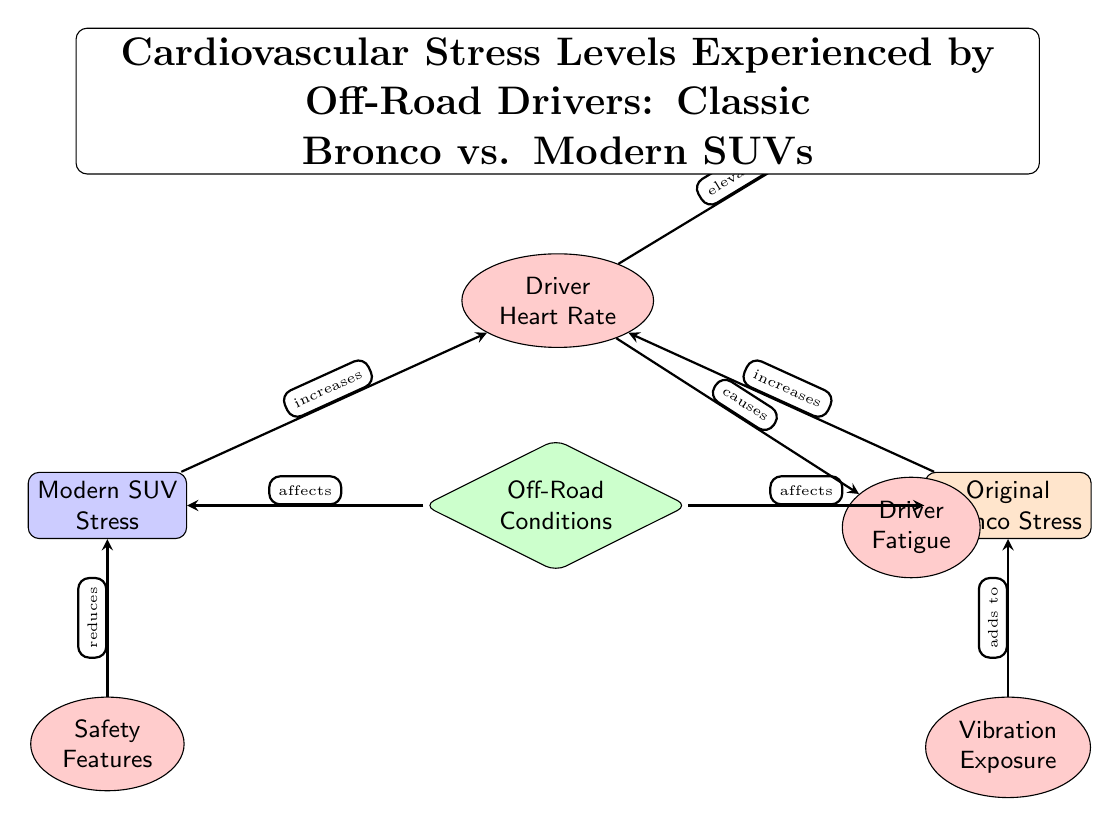What condition affects both vehicle types? The diagram indicates "Off-Road Conditions" as a condition that directly affects both the Original Bronco and Modern SUV. This can be seen from the arrows connecting the off-road node to both vehicle nodes.
Answer: Off-Road Conditions What emotional response is elevated due to the driver's heart rate? According to the diagram, the heart rate is directly linked to "Adrenaline Levels," which is shown above the heart rate node with a connecting arrow indicating an increase.
Answer: Adrenaline Levels Which vehicle has an effect from vibration exposure? The diagram shows that the "Vibration Exposure" node is connected to the Original Bronco node, indicating that the Bronco is affected by vibration exposure while the Modern SUV is not shown to have this effect.
Answer: Original Bronco How do safety features relate to cardiovascular stress? The diagram illustrates that "Safety Features" in the Modern SUV reduce its associated stress. This relationship is depicted by the arrow pointing from safety features to the Modern SUV node.
Answer: Reduces What two effects stem directly from the driver's heart rate? The diagram shows that the heart rate causes two significant effects: "Adrenaline Levels" and "Driver Fatigue." These are both positioned below the heart rate node with arrows leading from the heart rate to each effect.
Answer: Adrenaline Levels, Driver Fatigue 